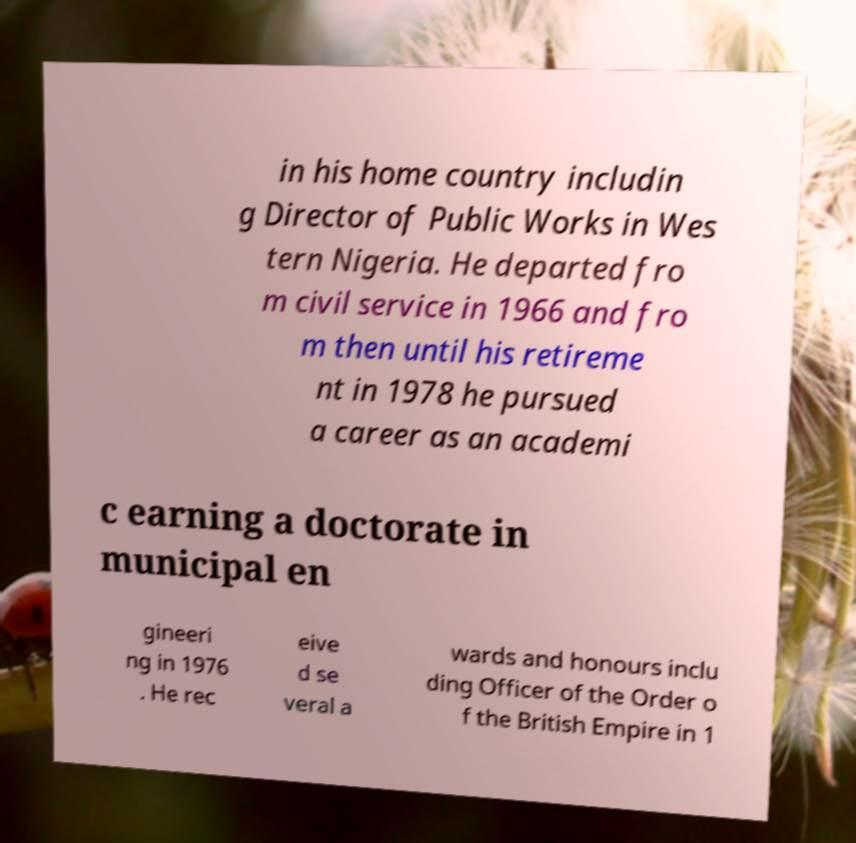Please identify and transcribe the text found in this image. in his home country includin g Director of Public Works in Wes tern Nigeria. He departed fro m civil service in 1966 and fro m then until his retireme nt in 1978 he pursued a career as an academi c earning a doctorate in municipal en gineeri ng in 1976 . He rec eive d se veral a wards and honours inclu ding Officer of the Order o f the British Empire in 1 